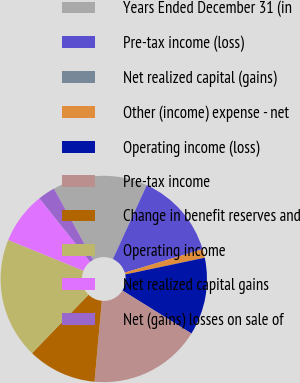Convert chart to OTSL. <chart><loc_0><loc_0><loc_500><loc_500><pie_chart><fcel>Years Ended December 31 (in<fcel>Pre-tax income (loss)<fcel>Net realized capital (gains)<fcel>Other (income) expense - net<fcel>Operating income (loss)<fcel>Pre-tax income<fcel>Change in benefit reserves and<fcel>Operating income<fcel>Net realized capital gains<fcel>Net (gains) losses on sale of<nl><fcel>14.86%<fcel>13.51%<fcel>0.0%<fcel>1.35%<fcel>12.16%<fcel>17.57%<fcel>10.81%<fcel>18.92%<fcel>8.11%<fcel>2.7%<nl></chart> 